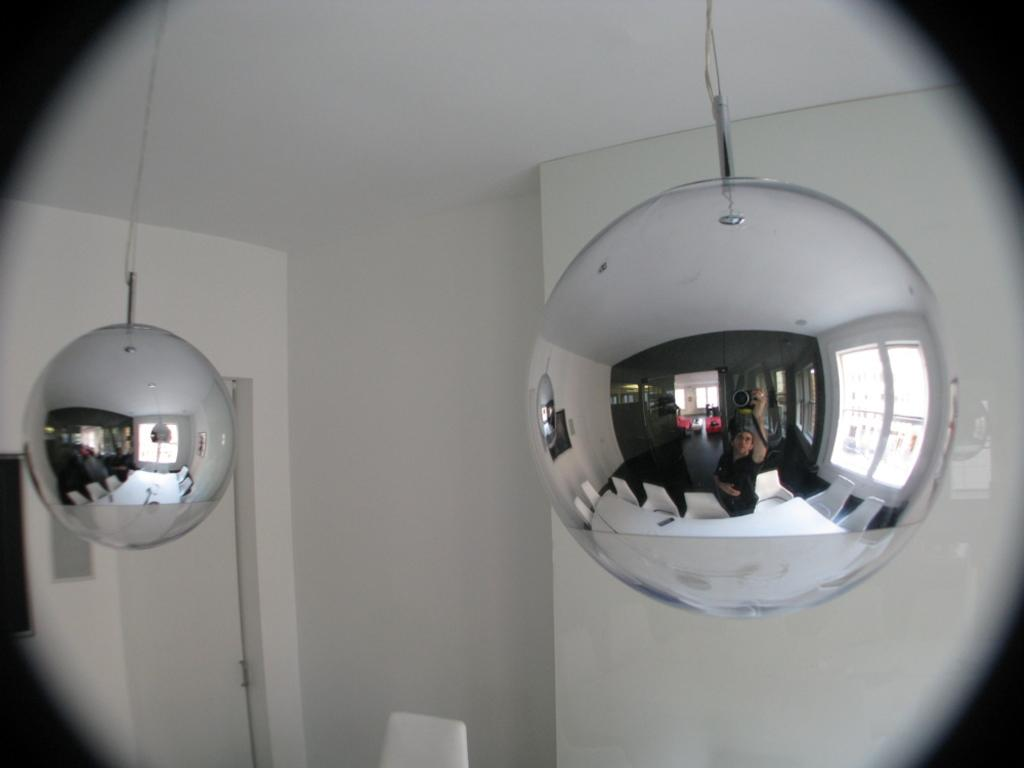What objects are hanging on the wall in the image? There are two metal pendulums in the image, and they are hanged on the wall. What can be observed in the pendulums? There are reflections visible in the pendulums. What can be seen in the background of the image? There is a door and a wall in the background of the image. How does the coach provide comfort to the pendulums in the image? There is no coach present in the image, and the pendulums do not require comfort. 